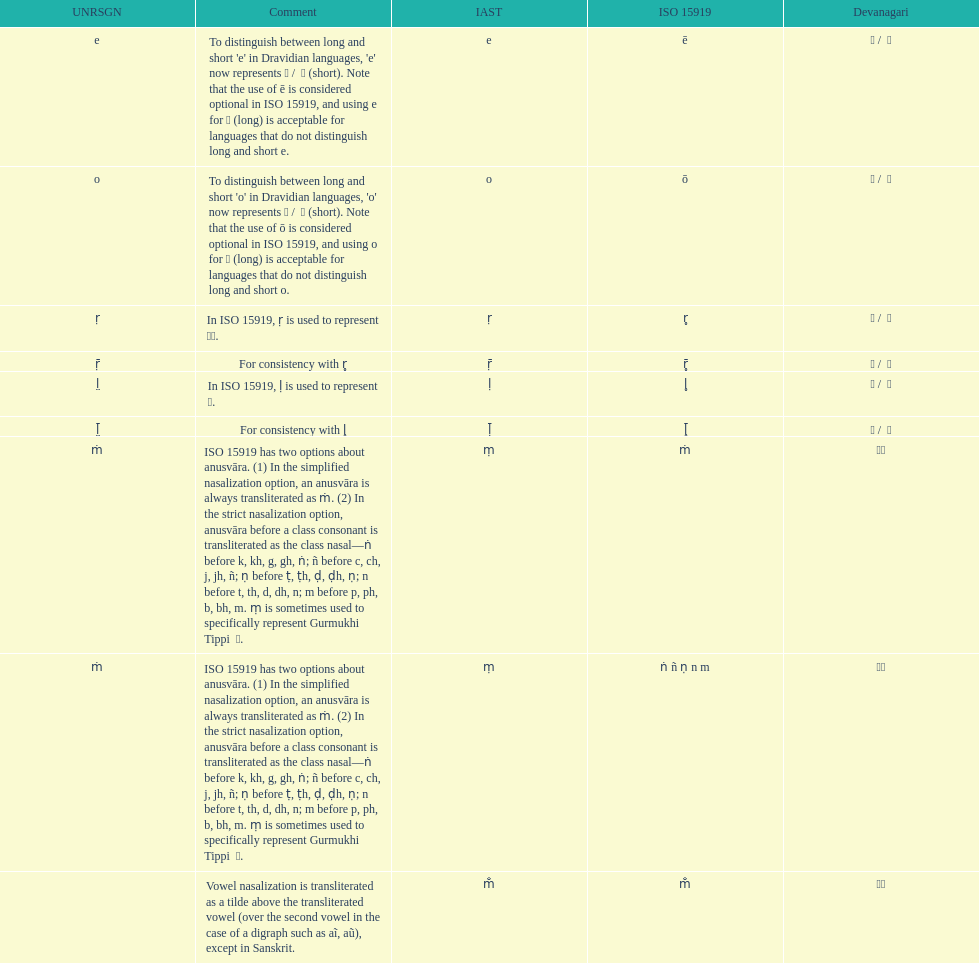What iast is listed before the o? E. Can you give me this table as a dict? {'header': ['UNRSGN', 'Comment', 'IAST', 'ISO 15919', 'Devanagari'], 'rows': [['e', "To distinguish between long and short 'e' in Dravidian languages, 'e' now represents ऎ / \xa0ॆ (short). Note that the use of ē is considered optional in ISO 15919, and using e for ए (long) is acceptable for languages that do not distinguish long and short e.", 'e', 'ē', 'ए / \xa0े'], ['o', "To distinguish between long and short 'o' in Dravidian languages, 'o' now represents ऒ / \xa0ॊ (short). Note that the use of ō is considered optional in ISO 15919, and using o for ओ (long) is acceptable for languages that do not distinguish long and short o.", 'o', 'ō', 'ओ / \xa0ो'], ['ṛ', 'In ISO 15919, ṛ is used to represent ड़.', 'ṛ', 'r̥', 'ऋ / \xa0ृ'], ['ṝ', 'For consistency with r̥', 'ṝ', 'r̥̄', 'ॠ / \xa0ॄ'], ['l̤', 'In ISO 15919, ḷ is used to represent ळ.', 'ḷ', 'l̥', 'ऌ / \xa0ॢ'], ['l̤̄', 'For consistency with l̥', 'ḹ', 'l̥̄', 'ॡ / \xa0ॣ'], ['ṁ', 'ISO 15919 has two options about anusvāra. (1) In the simplified nasalization option, an anusvāra is always transliterated as ṁ. (2) In the strict nasalization option, anusvāra before a class consonant is transliterated as the class nasal—ṅ before k, kh, g, gh, ṅ; ñ before c, ch, j, jh, ñ; ṇ before ṭ, ṭh, ḍ, ḍh, ṇ; n before t, th, d, dh, n; m before p, ph, b, bh, m. ṃ is sometimes used to specifically represent Gurmukhi Tippi \xa0ੰ.', 'ṃ', 'ṁ', '◌ं'], ['ṁ', 'ISO 15919 has two options about anusvāra. (1) In the simplified nasalization option, an anusvāra is always transliterated as ṁ. (2) In the strict nasalization option, anusvāra before a class consonant is transliterated as the class nasal—ṅ before k, kh, g, gh, ṅ; ñ before c, ch, j, jh, ñ; ṇ before ṭ, ṭh, ḍ, ḍh, ṇ; n before t, th, d, dh, n; m before p, ph, b, bh, m. ṃ is sometimes used to specifically represent Gurmukhi Tippi \xa0ੰ.', 'ṃ', 'ṅ ñ ṇ n m', '◌ं'], ['', 'Vowel nasalization is transliterated as a tilde above the transliterated vowel (over the second vowel in the case of a digraph such as aĩ, aũ), except in Sanskrit.', 'm̐', 'm̐', '◌ँ']]} 